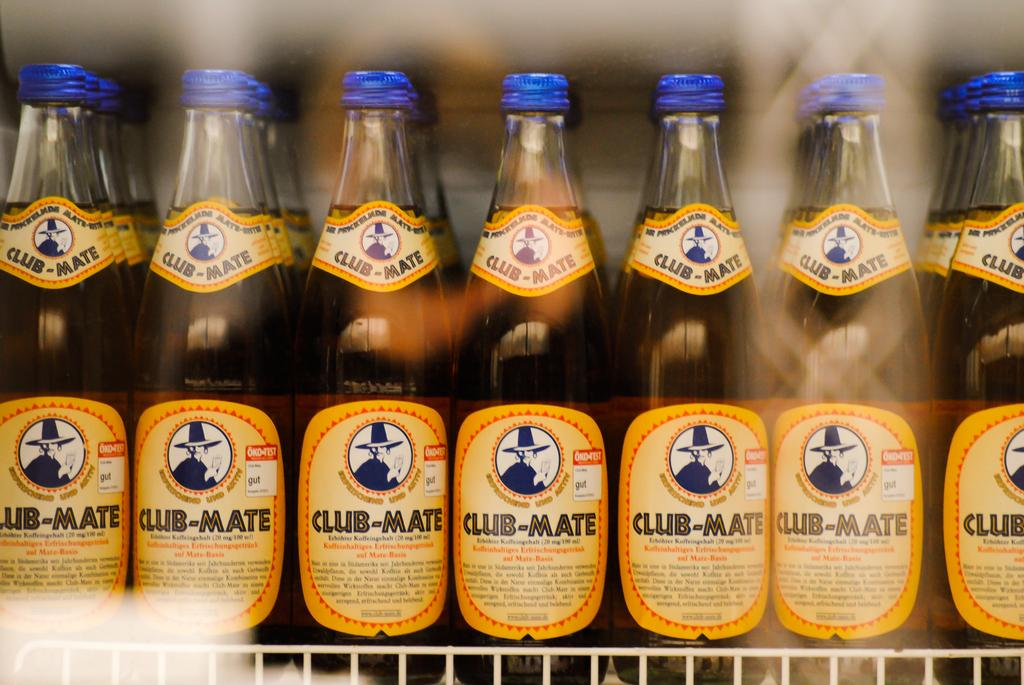<image>
Describe the image concisely. The image is of a horizontal row of bottles with the label saying "club mate." 